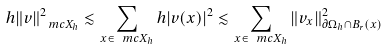<formula> <loc_0><loc_0><loc_500><loc_500>h \| v \| ^ { 2 } _ { \ m c X _ { h } } \lesssim \sum _ { x \in \ m c X _ { h } } h | v ( x ) | ^ { 2 } \lesssim \sum _ { x \in \ m c X _ { h } } \| v _ { x } \| ^ { 2 } _ { \partial \Omega _ { h } \cap B _ { r } ( x ) }</formula> 